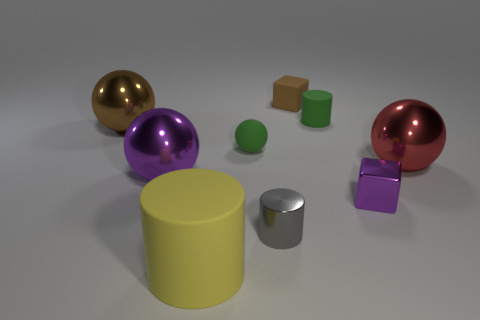How many tiny blue matte objects have the same shape as the large purple metal object?
Ensure brevity in your answer.  0. What number of small objects are green rubber objects or gray rubber things?
Ensure brevity in your answer.  2. Does the cylinder behind the brown sphere have the same color as the metal cylinder?
Your response must be concise. No. Do the big thing on the right side of the small ball and the block behind the small green rubber cylinder have the same color?
Provide a short and direct response. No. Is there a brown object made of the same material as the purple sphere?
Your response must be concise. Yes. What number of brown things are either matte blocks or small matte spheres?
Your answer should be compact. 1. Is the number of red metallic things that are on the left side of the small metal cylinder greater than the number of tiny gray objects?
Offer a terse response. No. Is the size of the yellow cylinder the same as the green matte cylinder?
Provide a succinct answer. No. What color is the small cylinder that is made of the same material as the purple cube?
Give a very brief answer. Gray. What is the shape of the matte thing that is the same color as the small ball?
Provide a succinct answer. Cylinder. 